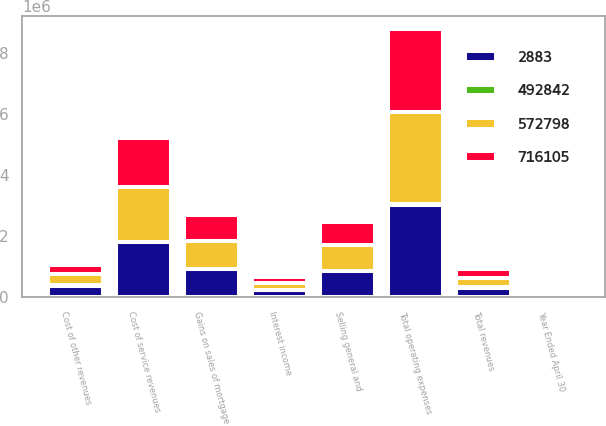<chart> <loc_0><loc_0><loc_500><loc_500><stacked_bar_chart><ecel><fcel>Year Ended April 30<fcel>Gains on sales of mortgage<fcel>Interest income<fcel>Total revenues<fcel>Cost of service revenues<fcel>Cost of other revenues<fcel>Selling general and<fcel>Total operating expenses<nl><fcel>572798<fcel>2004<fcel>913699<fcel>211359<fcel>295975<fcel>1.78709e+06<fcel>375713<fcel>836523<fcel>2.99932e+06<nl><fcel>492842<fcel>2004<fcel>4598<fcel>18436<fcel>23034<fcel>7412<fcel>4652<fcel>12152<fcel>24216<nl><fcel>2883<fcel>2004<fcel>918297<fcel>229795<fcel>295975<fcel>1.7945e+06<fcel>380365<fcel>848675<fcel>3.02354e+06<nl><fcel>716105<fcel>2003<fcel>864701<fcel>193889<fcel>295975<fcel>1.6236e+06<fcel>295975<fcel>755203<fcel>2.71056e+06<nl></chart> 